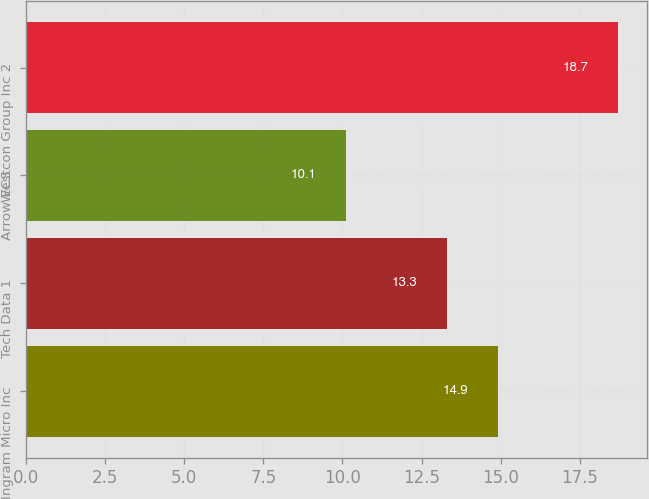Convert chart to OTSL. <chart><loc_0><loc_0><loc_500><loc_500><bar_chart><fcel>Ingram Micro Inc<fcel>Tech Data 1<fcel>Arrow ECS<fcel>Westcon Group Inc 2<nl><fcel>14.9<fcel>13.3<fcel>10.1<fcel>18.7<nl></chart> 